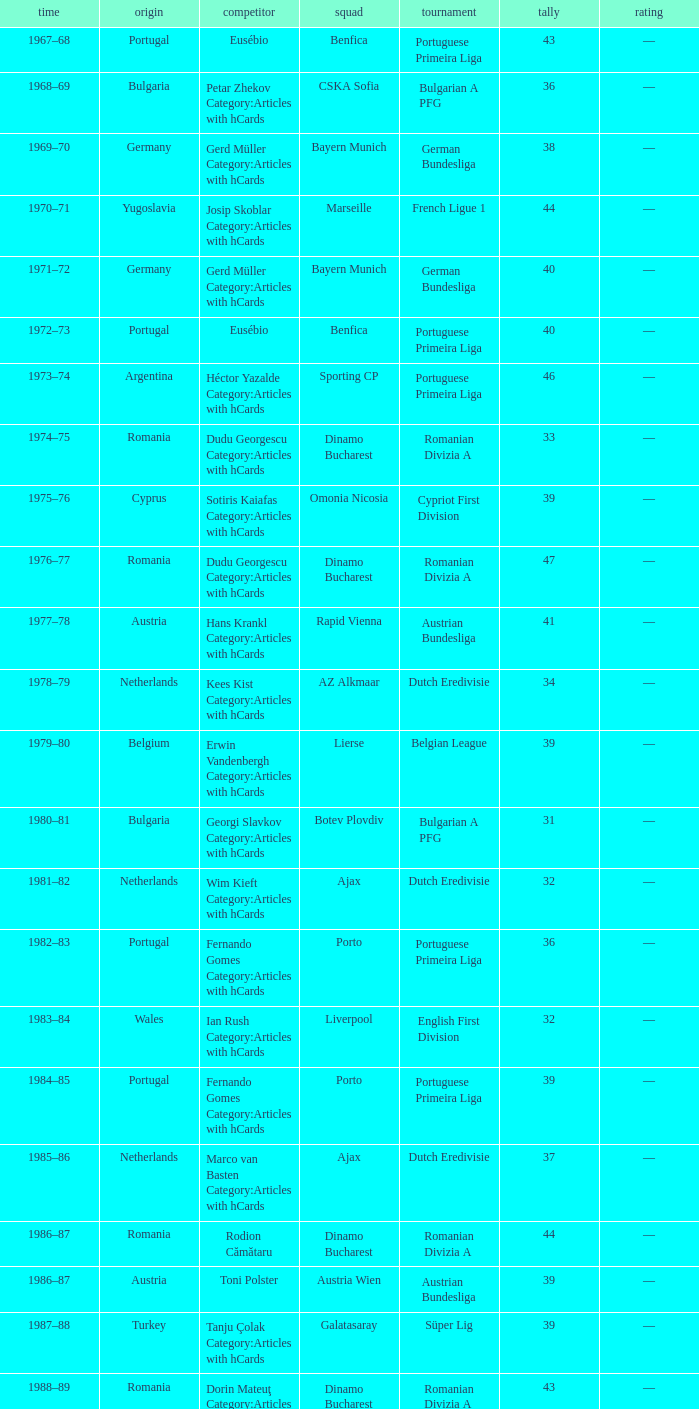Which league's nationality was Italy when there were 62 points? Italian Serie A. 